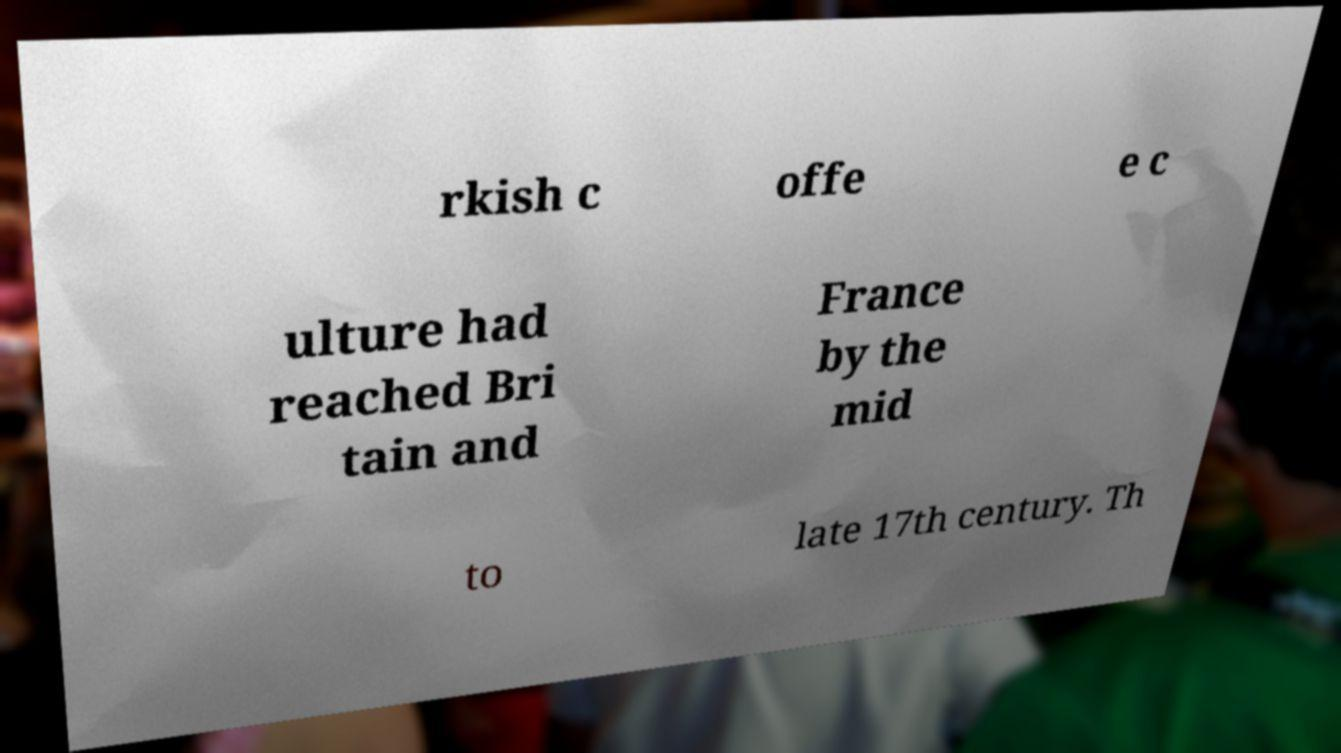There's text embedded in this image that I need extracted. Can you transcribe it verbatim? rkish c offe e c ulture had reached Bri tain and France by the mid to late 17th century. Th 